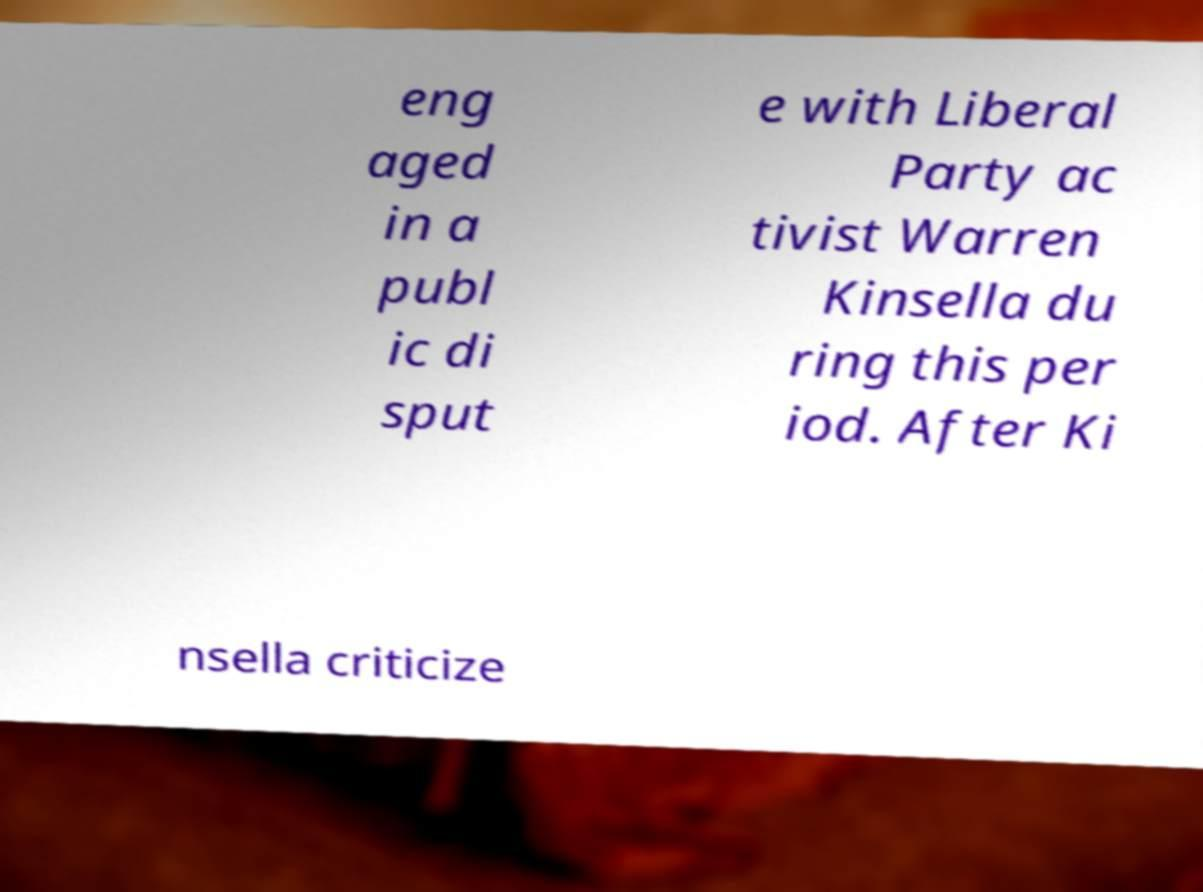Could you assist in decoding the text presented in this image and type it out clearly? eng aged in a publ ic di sput e with Liberal Party ac tivist Warren Kinsella du ring this per iod. After Ki nsella criticize 